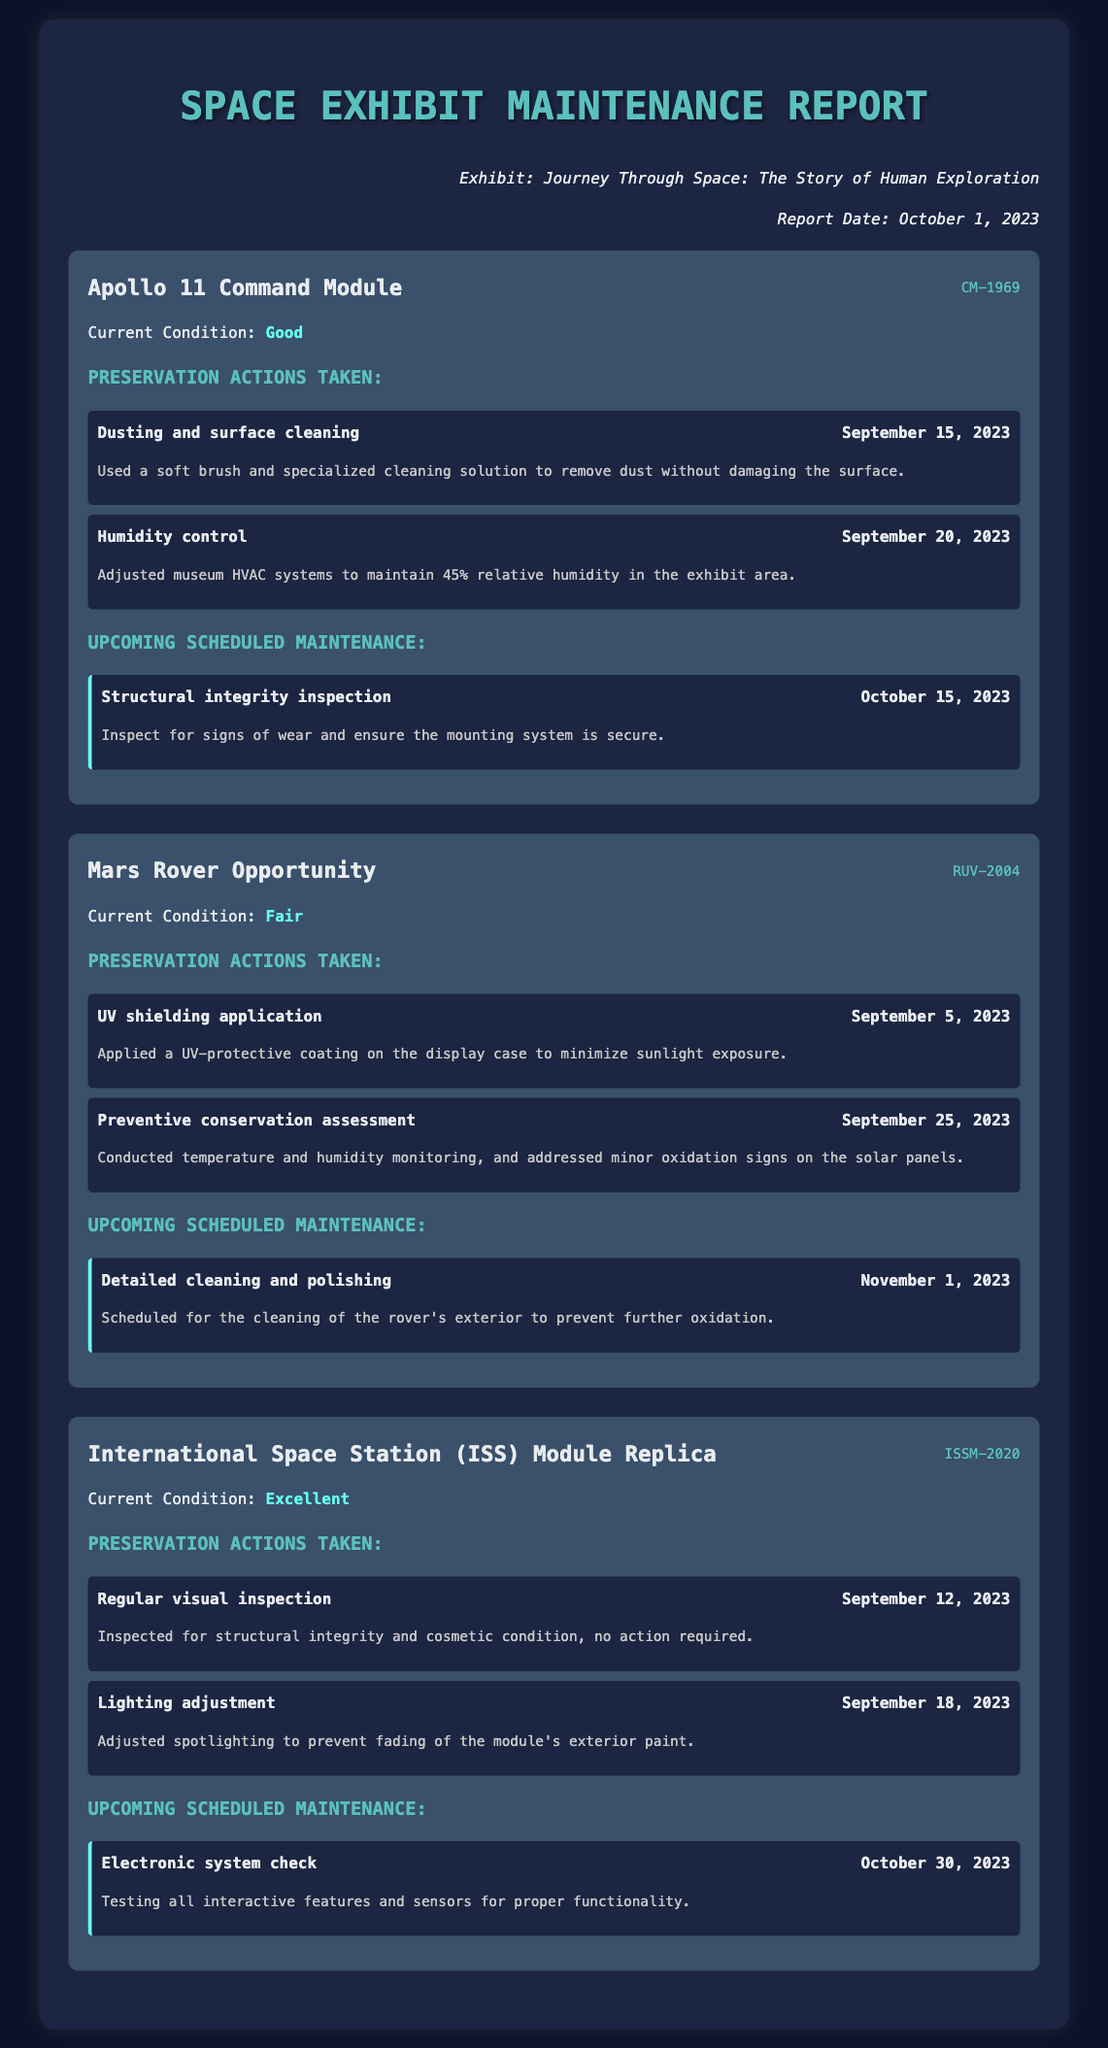What is the current condition of the Apollo 11 Command Module? The document states that the current condition of the Apollo 11 Command Module is "Good."
Answer: Good When is the scheduled maintenance for the Mars Rover Opportunity? The document lists the upcoming scheduled maintenance for the Mars Rover Opportunity as occurring on "November 1, 2023."
Answer: November 1, 2023 What preservation action was taken on September 5, 2023, for the Mars Rover Opportunity? The document indicates that a UV shielding application was performed on that date.
Answer: UV shielding application How many preservation actions are listed for the International Space Station Module Replica? There are two preservation actions listed for the International Space Station Module Replica.
Answer: Two What is the upcoming scheduled maintenance for the Apollo 11 Command Module? The document specifies that a structural integrity inspection is scheduled for October 15, 2023.
Answer: Structural integrity inspection What was adjusted to maintain a specific humidity level in the Apollo 11 exhibit area? The document mentions that the museum HVAC systems were adjusted for humidity control.
Answer: HVAC systems What is the action taken on September 12, 2023, regarding the ISS Module Replica? The document notes that a regular visual inspection was conducted on that date.
Answer: Regular visual inspection Which item has the current condition labeled as "Fair"? The document states that the Mars Rover Opportunity has a current condition of "Fair."
Answer: Mars Rover Opportunity 